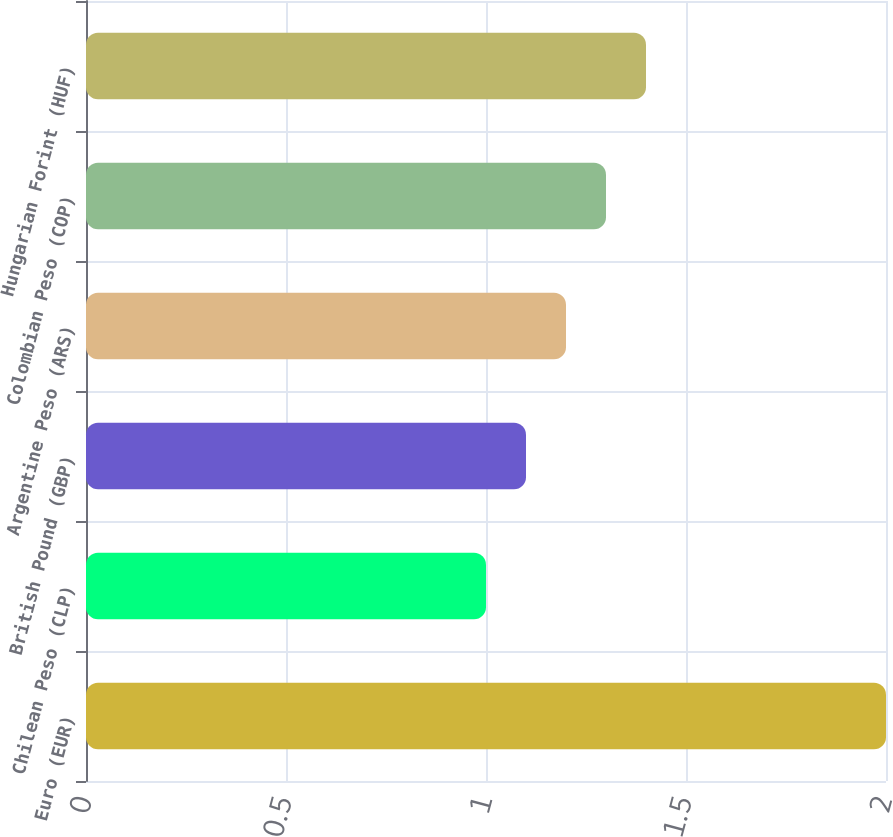Convert chart to OTSL. <chart><loc_0><loc_0><loc_500><loc_500><bar_chart><fcel>Euro (EUR)<fcel>Chilean Peso (CLP)<fcel>British Pound (GBP)<fcel>Argentine Peso (ARS)<fcel>Colombian Peso (COP)<fcel>Hungarian Forint (HUF)<nl><fcel>2<fcel>1<fcel>1.1<fcel>1.2<fcel>1.3<fcel>1.4<nl></chart> 